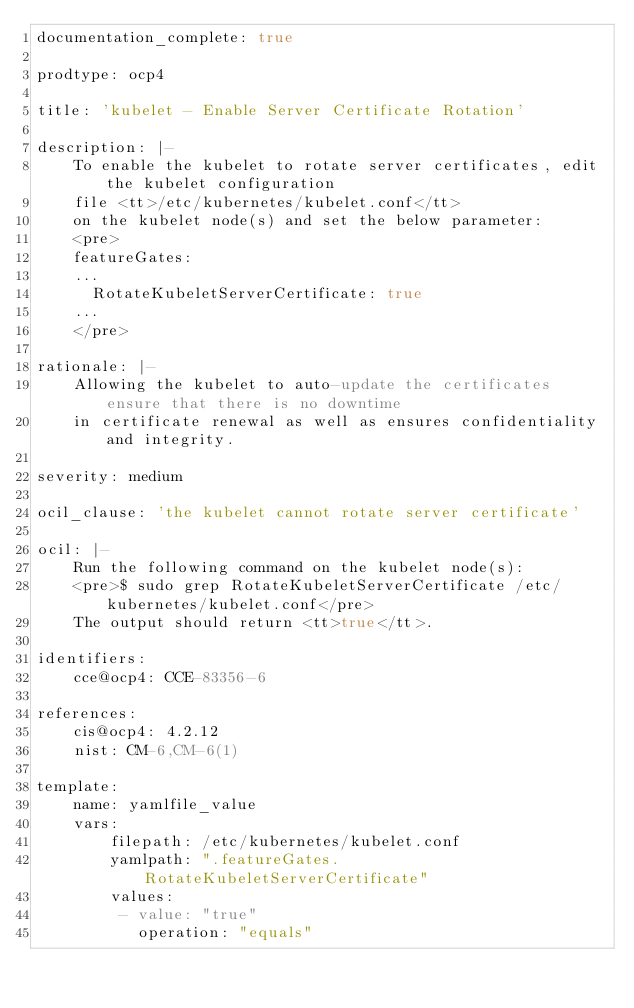<code> <loc_0><loc_0><loc_500><loc_500><_YAML_>documentation_complete: true

prodtype: ocp4

title: 'kubelet - Enable Server Certificate Rotation'

description: |-
    To enable the kubelet to rotate server certificates, edit the kubelet configuration
    file <tt>/etc/kubernetes/kubelet.conf</tt>
    on the kubelet node(s) and set the below parameter:
    <pre>
    featureGates:
    ...
      RotateKubeletServerCertificate: true
    ...
    </pre>

rationale: |-
    Allowing the kubelet to auto-update the certificates ensure that there is no downtime
    in certificate renewal as well as ensures confidentiality and integrity.

severity: medium

ocil_clause: 'the kubelet cannot rotate server certificate'

ocil: |-
    Run the following command on the kubelet node(s):
    <pre>$ sudo grep RotateKubeletServerCertificate /etc/kubernetes/kubelet.conf</pre>
    The output should return <tt>true</tt>.

identifiers:
    cce@ocp4: CCE-83356-6

references:
    cis@ocp4: 4.2.12
    nist: CM-6,CM-6(1)

template:
    name: yamlfile_value
    vars:
        filepath: /etc/kubernetes/kubelet.conf
        yamlpath: ".featureGates.RotateKubeletServerCertificate"
        values:
         - value: "true"
           operation: "equals"
</code> 